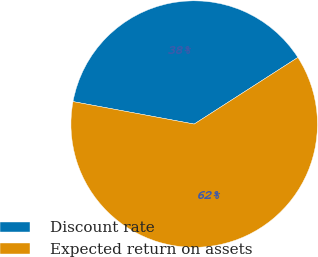<chart> <loc_0><loc_0><loc_500><loc_500><pie_chart><fcel>Discount rate<fcel>Expected return on assets<nl><fcel>37.99%<fcel>62.01%<nl></chart> 